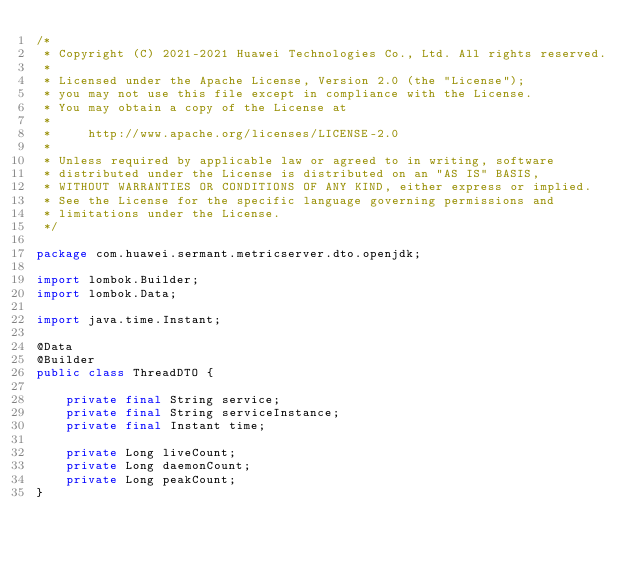<code> <loc_0><loc_0><loc_500><loc_500><_Java_>/*
 * Copyright (C) 2021-2021 Huawei Technologies Co., Ltd. All rights reserved.
 *
 * Licensed under the Apache License, Version 2.0 (the "License");
 * you may not use this file except in compliance with the License.
 * You may obtain a copy of the License at
 *
 *     http://www.apache.org/licenses/LICENSE-2.0
 *
 * Unless required by applicable law or agreed to in writing, software
 * distributed under the License is distributed on an "AS IS" BASIS,
 * WITHOUT WARRANTIES OR CONDITIONS OF ANY KIND, either express or implied.
 * See the License for the specific language governing permissions and
 * limitations under the License.
 */

package com.huawei.sermant.metricserver.dto.openjdk;

import lombok.Builder;
import lombok.Data;

import java.time.Instant;

@Data
@Builder
public class ThreadDTO {

    private final String service;
    private final String serviceInstance;
    private final Instant time;

    private Long liveCount;
    private Long daemonCount;
    private Long peakCount;
}
</code> 